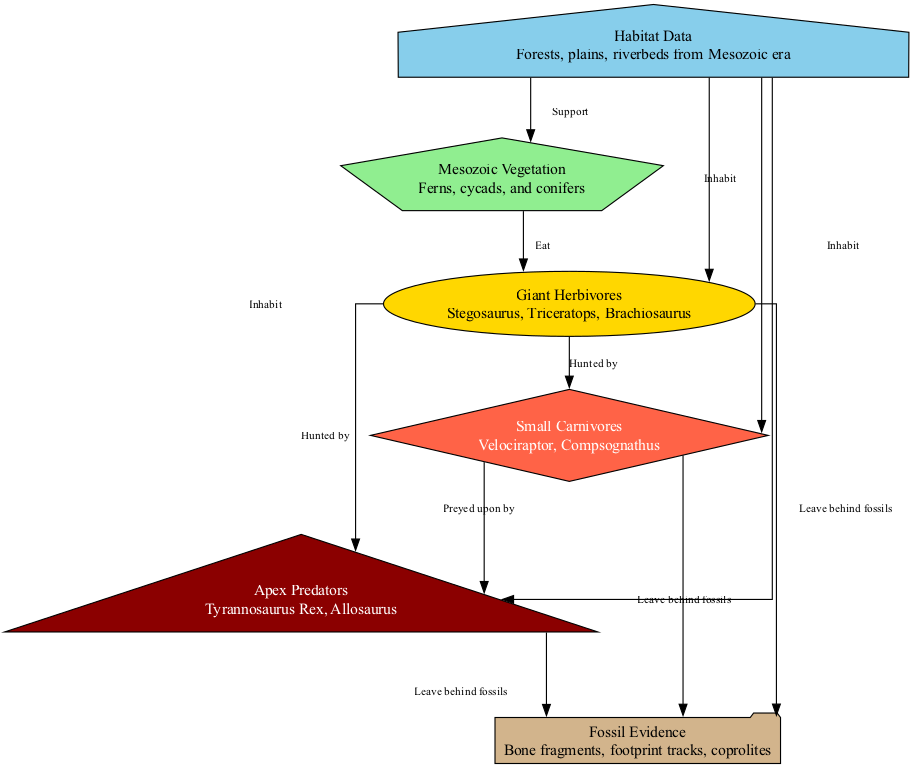How many nodes are in the diagram? The diagram contains six nodes: Plants, Herbivores, Carnivores, Apex Predators, Fossils, and Habitats. Counting each of these gives the total.
Answer: 6 What do herbivores eat? The label on the edge leading from Plants to Herbivores indicates that herbivores eat plants. This can be directly inferred from the diagram's relationships.
Answer: Plants Which type of dinosaur is a carnivore? The node labeled "Carnivores" describes small carnivorous dinosaurs like Velociraptor and Compsognathus. Thus, any dinosaur in this category corresponds to this description.
Answer: Velociraptor What leaves behind fossils? The edges show that Herbivores, Carnivores, and Apex Predators all leave behind fossils, as indicated by the relationships leading to the Fossils node.
Answer: Herbivores, Carnivores, and Apex Predators Which organisms inhabit the forests? The Habitats node is connected to Plants, Herbivores, Carnivores, and Apex Predators, so all these organisms inhabit forests, as the diagram indicates support for them.
Answer: Plants, Herbivores, Carnivores, Apex Predators Who hunts the herbivores? The diagram shows two edges leading from Herbivores to Carnivores and Apex Predators, indicating that both groups hunt the herbivores. Hence, both are valid answers to this question.
Answer: Carnivores, Apex Predators How many apex predators are listed in the diagram? According to the node labeled "Apex Predators," there are two specific examples: Tyrannosaurus Rex and Allosaurus. Counting these gives us the total number of apex predators represented.
Answer: 2 What is the relationship between carnivores and apex predators? The diagram indicates that carnivores are preyed upon by apex predators, based on the connection shown from Carnivores to Apex Predators. This understanding leads to knowing their ecological relationship.
Answer: Preyed upon by What supports the Mesozoic vegetation? The connection leading from the Habitats node to the Plants node shows that habitats support Mesozoic vegetation, implying that the various habitat types prevalent in that era promote plant growth.
Answer: Habitats 